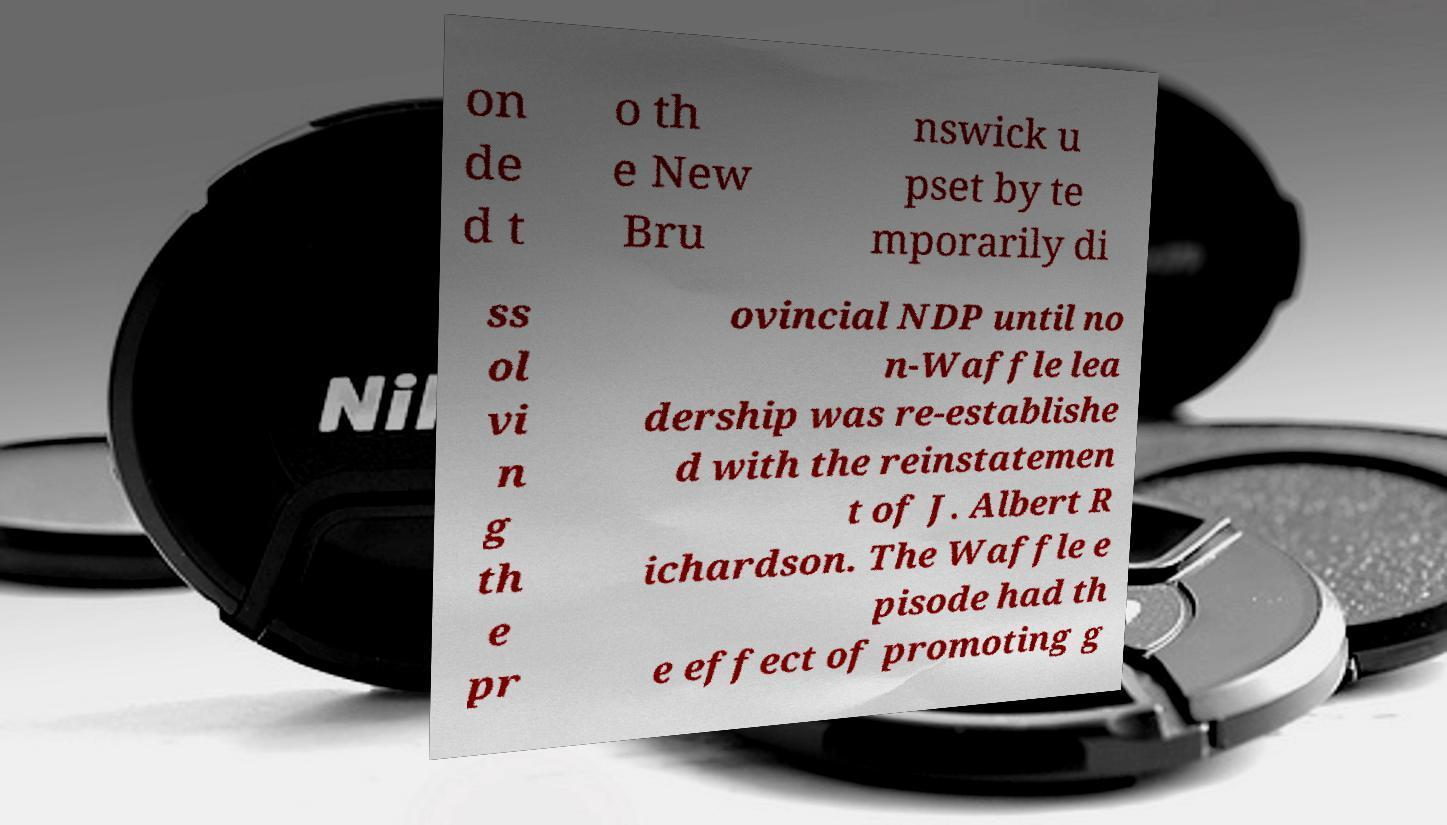Could you assist in decoding the text presented in this image and type it out clearly? on de d t o th e New Bru nswick u pset by te mporarily di ss ol vi n g th e pr ovincial NDP until no n-Waffle lea dership was re-establishe d with the reinstatemen t of J. Albert R ichardson. The Waffle e pisode had th e effect of promoting g 